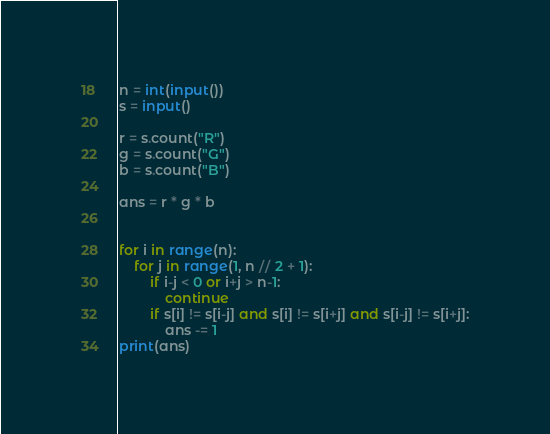<code> <loc_0><loc_0><loc_500><loc_500><_Python_>n = int(input())
s = input()

r = s.count("R")
g = s.count("G")
b = s.count("B")

ans = r * g * b


for i in range(n):
    for j in range(1, n // 2 + 1):
        if i-j < 0 or i+j > n-1:
            continue
        if s[i] != s[i-j] and s[i] != s[i+j] and s[i-j] != s[i+j]:
            ans -= 1
print(ans)

</code> 